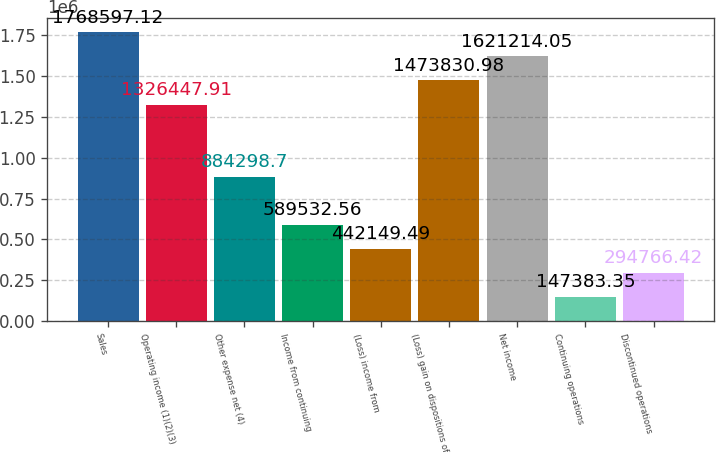Convert chart. <chart><loc_0><loc_0><loc_500><loc_500><bar_chart><fcel>Sales<fcel>Operating income (1)(2)(3)<fcel>Other expense net (4)<fcel>Income from continuing<fcel>(Loss) income from<fcel>(Loss) gain on dispositions of<fcel>Net income<fcel>Continuing operations<fcel>Discontinued operations<nl><fcel>1.7686e+06<fcel>1.32645e+06<fcel>884299<fcel>589533<fcel>442149<fcel>1.47383e+06<fcel>1.62121e+06<fcel>147383<fcel>294766<nl></chart> 